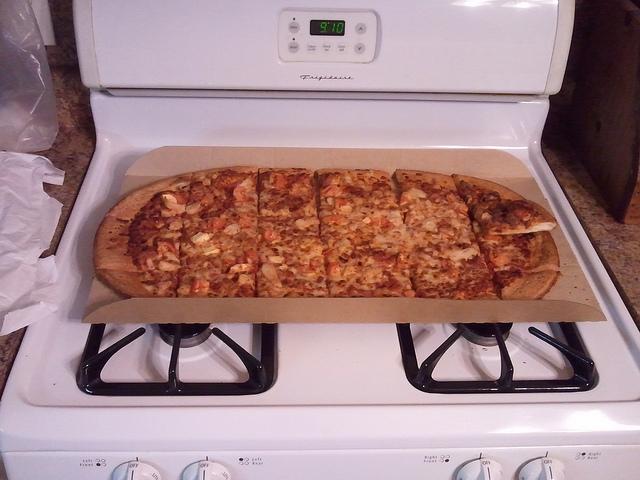Is the pizza on a baking tray?
Be succinct. No. What shape is the pizza?
Be succinct. Oval. Is the food cut?
Write a very short answer. Yes. 